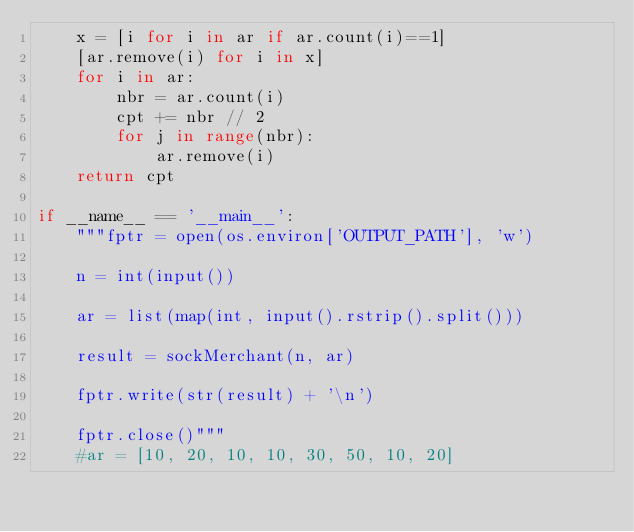Convert code to text. <code><loc_0><loc_0><loc_500><loc_500><_Python_>    x = [i for i in ar if ar.count(i)==1]
    [ar.remove(i) for i in x]
    for i in ar:
        nbr = ar.count(i)
        cpt += nbr // 2
        for j in range(nbr):
            ar.remove(i)
    return cpt

if __name__ == '__main__':
    """fptr = open(os.environ['OUTPUT_PATH'], 'w')

    n = int(input())

    ar = list(map(int, input().rstrip().split()))

    result = sockMerchant(n, ar)

    fptr.write(str(result) + '\n')

    fptr.close()"""
    #ar = [10, 20, 10, 10, 30, 50, 10, 20]</code> 